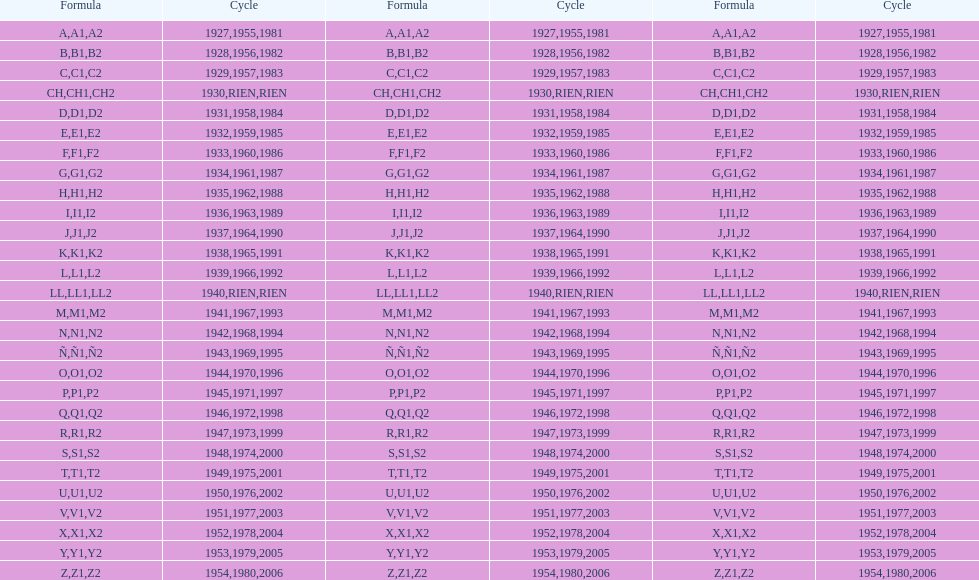What was the lowest year stamped? 1927. 